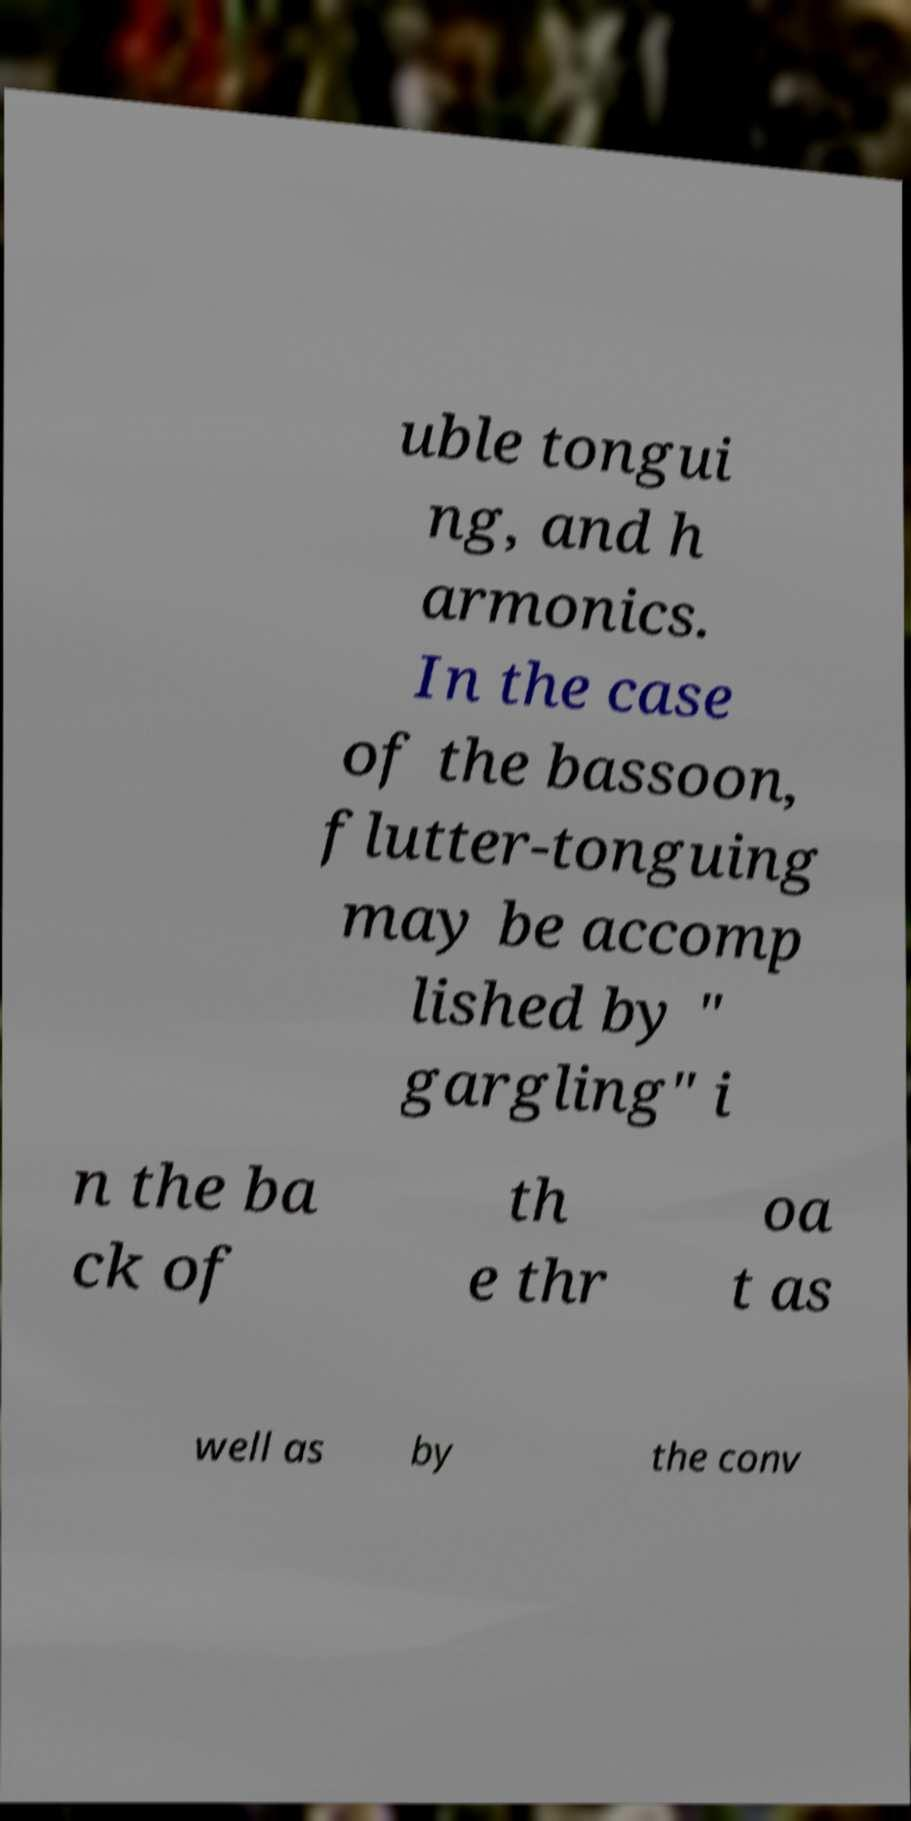Can you accurately transcribe the text from the provided image for me? uble tongui ng, and h armonics. In the case of the bassoon, flutter-tonguing may be accomp lished by " gargling" i n the ba ck of th e thr oa t as well as by the conv 